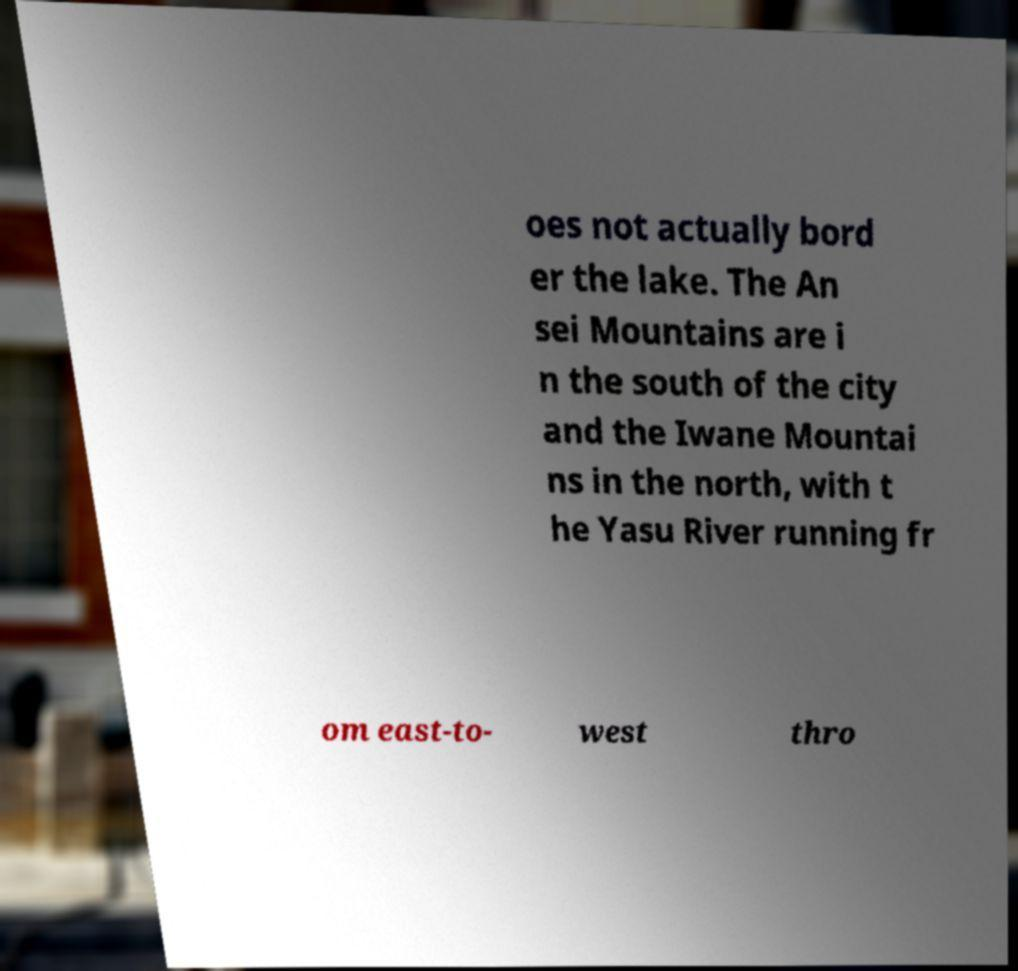Could you extract and type out the text from this image? oes not actually bord er the lake. The An sei Mountains are i n the south of the city and the Iwane Mountai ns in the north, with t he Yasu River running fr om east-to- west thro 